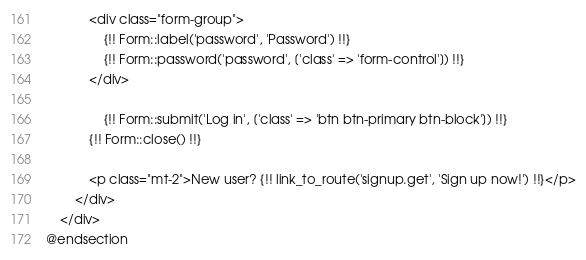<code> <loc_0><loc_0><loc_500><loc_500><_PHP_>            <div class="form-group">
                {!! Form::label('password', 'Password') !!}
                {!! Form::password('password', ['class' => 'form-control']) !!}
            </div>

                {!! Form::submit('Log in', ['class' => 'btn btn-primary btn-block']) !!}
            {!! Form::close() !!}

            <p class="mt-2">New user? {!! link_to_route('signup.get', 'Sign up now!') !!}</p>
        </div>
    </div>
@endsection</code> 